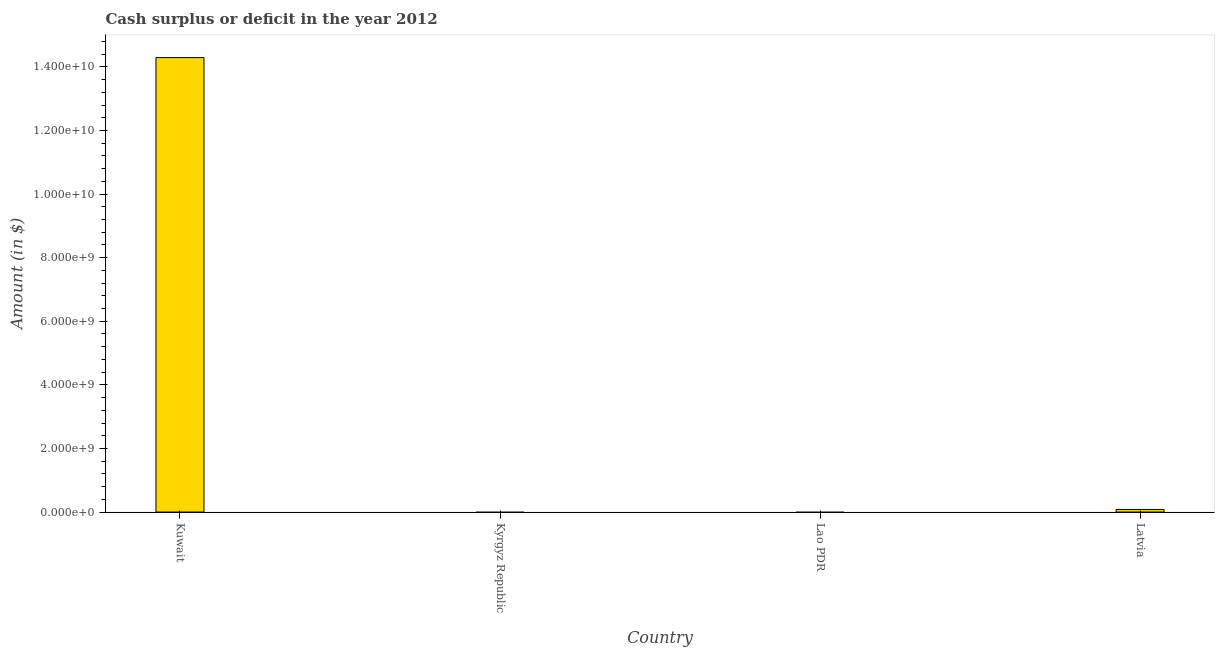What is the title of the graph?
Your response must be concise. Cash surplus or deficit in the year 2012. What is the label or title of the X-axis?
Offer a terse response. Country. What is the label or title of the Y-axis?
Offer a very short reply. Amount (in $). What is the cash surplus or deficit in Latvia?
Provide a short and direct response. 8.09e+07. Across all countries, what is the maximum cash surplus or deficit?
Keep it short and to the point. 1.43e+1. Across all countries, what is the minimum cash surplus or deficit?
Provide a succinct answer. 0. In which country was the cash surplus or deficit maximum?
Offer a very short reply. Kuwait. What is the sum of the cash surplus or deficit?
Make the answer very short. 1.44e+1. What is the difference between the cash surplus or deficit in Kuwait and Latvia?
Your answer should be compact. 1.42e+1. What is the average cash surplus or deficit per country?
Ensure brevity in your answer.  3.59e+09. What is the median cash surplus or deficit?
Provide a short and direct response. 4.05e+07. In how many countries, is the cash surplus or deficit greater than 12400000000 $?
Offer a very short reply. 1. Is the cash surplus or deficit in Kuwait less than that in Latvia?
Make the answer very short. No. Is the sum of the cash surplus or deficit in Kuwait and Latvia greater than the maximum cash surplus or deficit across all countries?
Provide a short and direct response. Yes. What is the difference between the highest and the lowest cash surplus or deficit?
Provide a short and direct response. 1.43e+1. How many bars are there?
Make the answer very short. 2. Are all the bars in the graph horizontal?
Offer a very short reply. No. Are the values on the major ticks of Y-axis written in scientific E-notation?
Your response must be concise. Yes. What is the Amount (in $) of Kuwait?
Make the answer very short. 1.43e+1. What is the Amount (in $) in Latvia?
Your response must be concise. 8.09e+07. What is the difference between the Amount (in $) in Kuwait and Latvia?
Give a very brief answer. 1.42e+1. What is the ratio of the Amount (in $) in Kuwait to that in Latvia?
Your response must be concise. 176.59. 